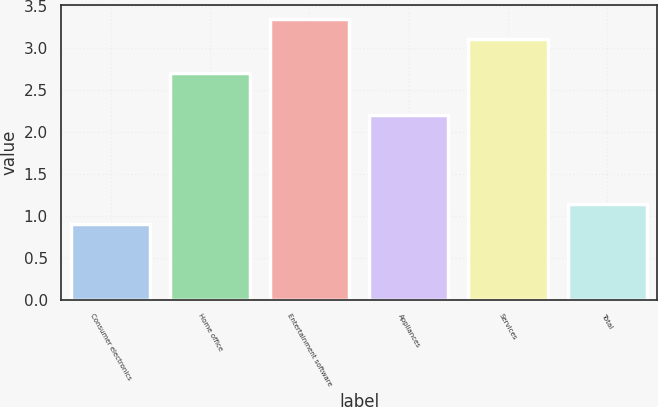Convert chart to OTSL. <chart><loc_0><loc_0><loc_500><loc_500><bar_chart><fcel>Consumer electronics<fcel>Home office<fcel>Entertainment software<fcel>Appliances<fcel>Services<fcel>Total<nl><fcel>0.9<fcel>2.7<fcel>3.34<fcel>2.2<fcel>3.1<fcel>1.14<nl></chart> 